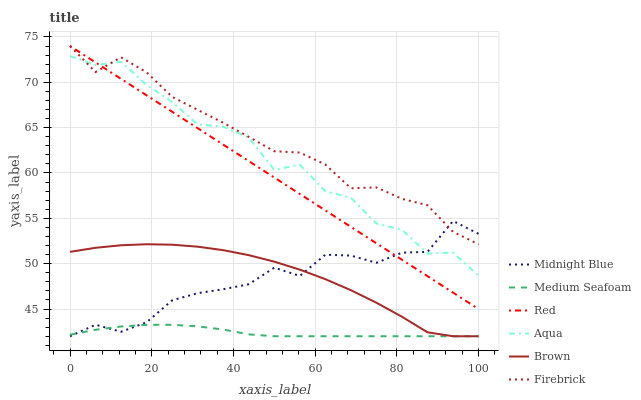Does Medium Seafoam have the minimum area under the curve?
Answer yes or no. Yes. Does Firebrick have the maximum area under the curve?
Answer yes or no. Yes. Does Midnight Blue have the minimum area under the curve?
Answer yes or no. No. Does Midnight Blue have the maximum area under the curve?
Answer yes or no. No. Is Red the smoothest?
Answer yes or no. Yes. Is Aqua the roughest?
Answer yes or no. Yes. Is Midnight Blue the smoothest?
Answer yes or no. No. Is Midnight Blue the roughest?
Answer yes or no. No. Does Brown have the lowest value?
Answer yes or no. Yes. Does Firebrick have the lowest value?
Answer yes or no. No. Does Red have the highest value?
Answer yes or no. Yes. Does Midnight Blue have the highest value?
Answer yes or no. No. Is Medium Seafoam less than Aqua?
Answer yes or no. Yes. Is Firebrick greater than Medium Seafoam?
Answer yes or no. Yes. Does Medium Seafoam intersect Brown?
Answer yes or no. Yes. Is Medium Seafoam less than Brown?
Answer yes or no. No. Is Medium Seafoam greater than Brown?
Answer yes or no. No. Does Medium Seafoam intersect Aqua?
Answer yes or no. No. 